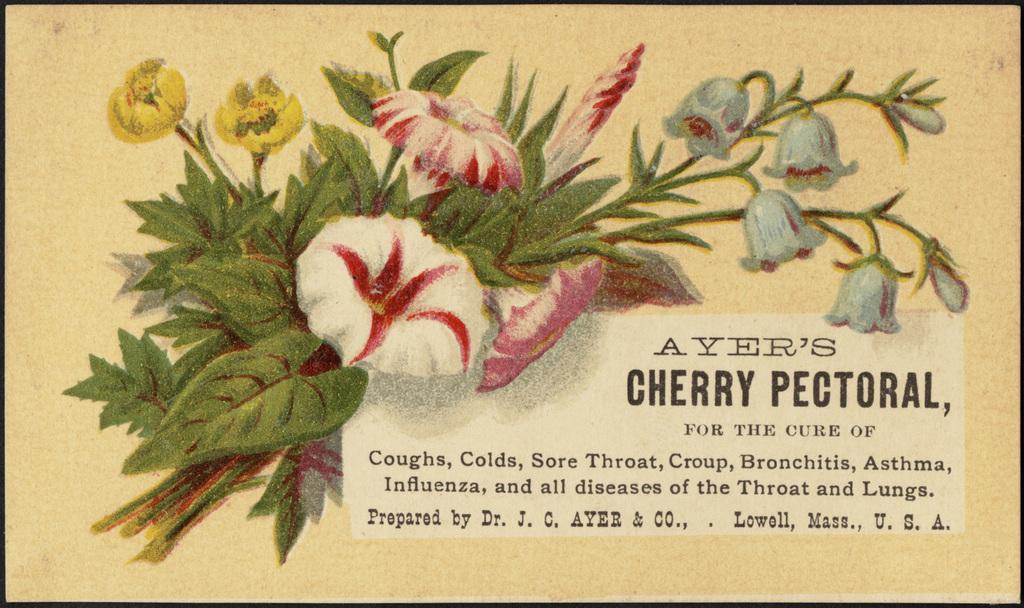Could you give a brief overview of what you see in this image? In this picture I can see there are few flowers and leaves painted and there is something written at the right bottom of the image. 